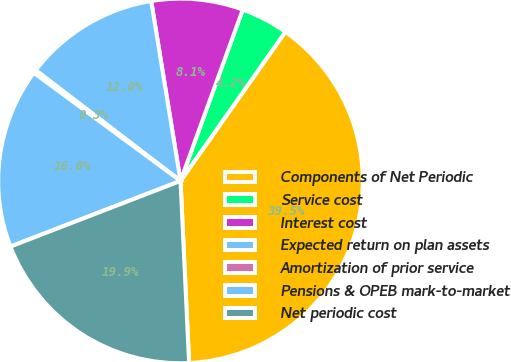<chart> <loc_0><loc_0><loc_500><loc_500><pie_chart><fcel>Components of Net Periodic<fcel>Service cost<fcel>Interest cost<fcel>Expected return on plan assets<fcel>Amortization of prior service<fcel>Pensions & OPEB mark-to-market<fcel>Net periodic cost<nl><fcel>39.5%<fcel>4.2%<fcel>8.12%<fcel>12.04%<fcel>0.28%<fcel>15.97%<fcel>19.89%<nl></chart> 